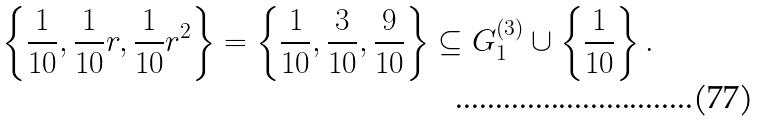Convert formula to latex. <formula><loc_0><loc_0><loc_500><loc_500>\left \{ \frac { 1 } { 1 0 } , \frac { 1 } { 1 0 } r , \frac { 1 } { 1 0 } r ^ { 2 } \right \} = \left \{ \frac { 1 } { 1 0 } , \frac { 3 } { 1 0 } , \frac { 9 } { 1 0 } \right \} \subseteq G _ { 1 } ^ { ( 3 ) } \cup \left \{ \frac { 1 } { 1 0 } \right \} .</formula> 